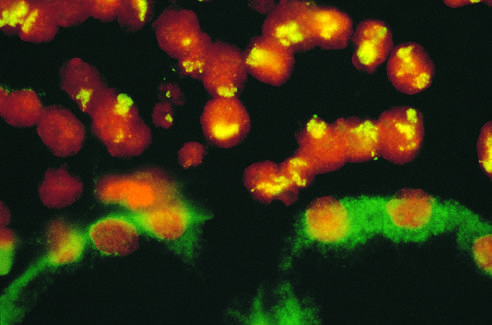does this correspond to amplified n-myc in the form of homogeneously staining regions?
Answer the question using a single word or phrase. Yes 